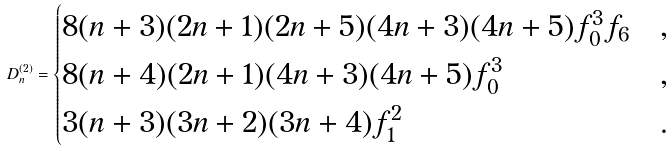<formula> <loc_0><loc_0><loc_500><loc_500>D _ { n } ^ { ( 2 ) } = \begin{cases} 8 ( n + 3 ) ( 2 n + 1 ) ( 2 n + 5 ) ( 4 n + 3 ) ( 4 n + 5 ) f _ { 0 } ^ { 3 } f _ { 6 } & , \\ 8 ( n + 4 ) ( 2 n + 1 ) ( 4 n + 3 ) ( 4 n + 5 ) f _ { 0 } ^ { 3 } & , \\ 3 ( n + 3 ) ( 3 n + 2 ) ( 3 n + 4 ) f _ { 1 } ^ { 2 } & . \end{cases}</formula> 